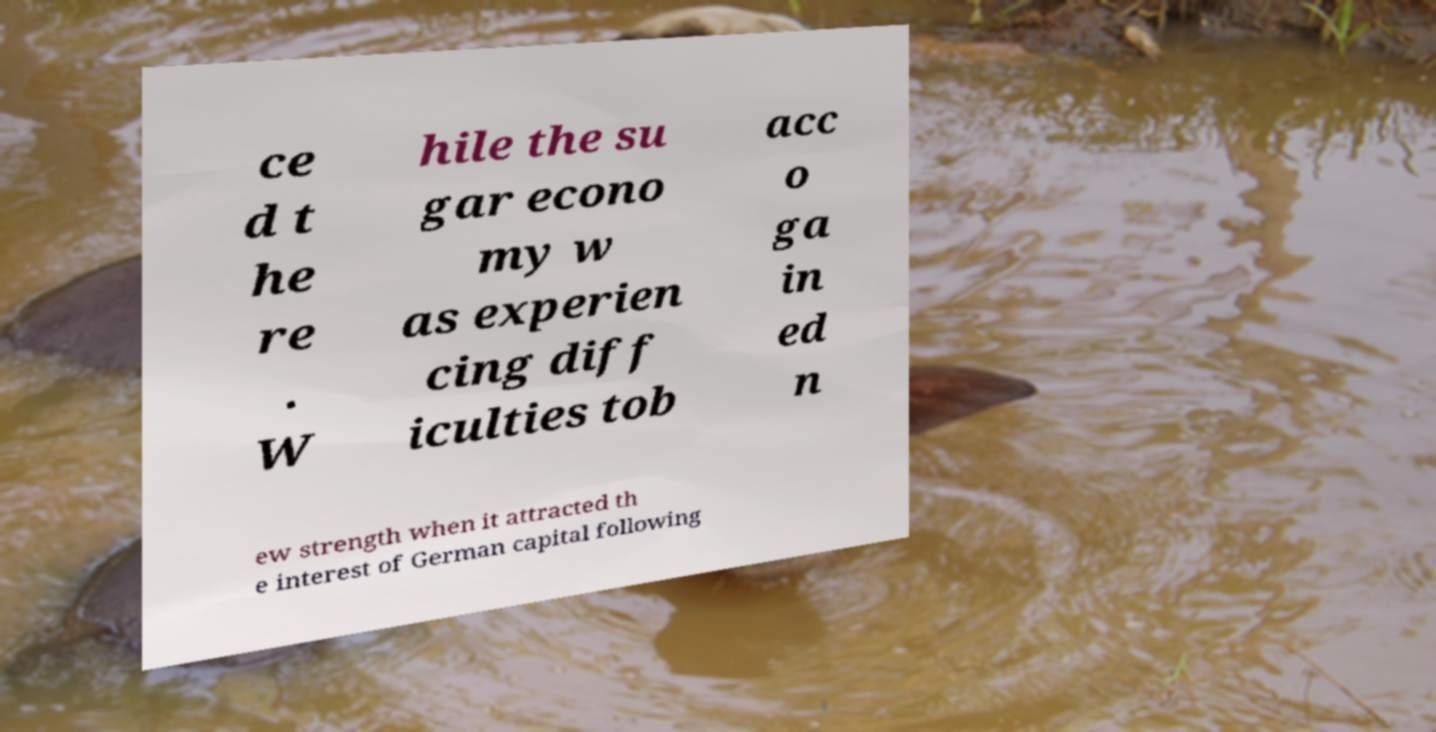Please read and relay the text visible in this image. What does it say? ce d t he re . W hile the su gar econo my w as experien cing diff iculties tob acc o ga in ed n ew strength when it attracted th e interest of German capital following 